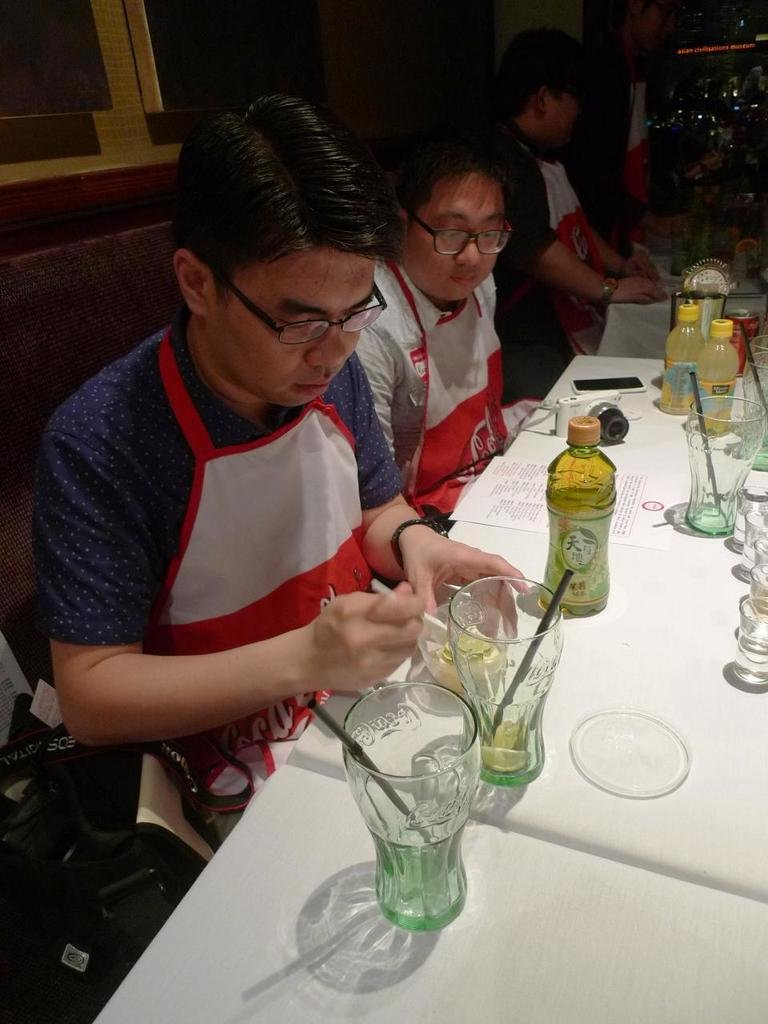What are the people in the image doing? The people in the image are sitting on chairs at a table. What objects can be seen on the table? There are glasses, bottles, a mobile phone, and a paper on the table. What might the people be using the glasses for? The glasses on the table might be used for drinking. What is the purpose of the mobile phone on the table? The mobile phone on the table might be used for communication or other functions. What type of skin is visible on the table in the image? There is no skin visible on the table in the image; it is a flat surface with objects on it. 